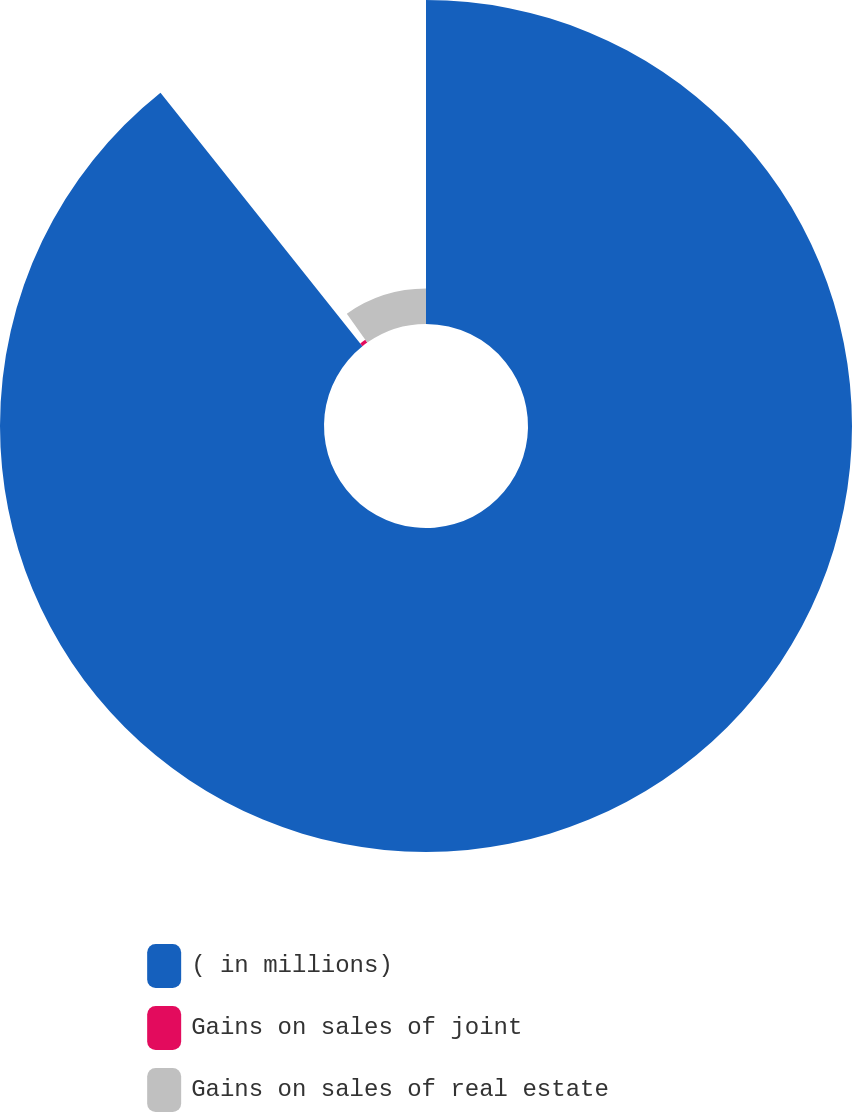Convert chart to OTSL. <chart><loc_0><loc_0><loc_500><loc_500><pie_chart><fcel>( in millions)<fcel>Gains on sales of joint<fcel>Gains on sales of real estate<nl><fcel>89.29%<fcel>0.94%<fcel>9.77%<nl></chart> 